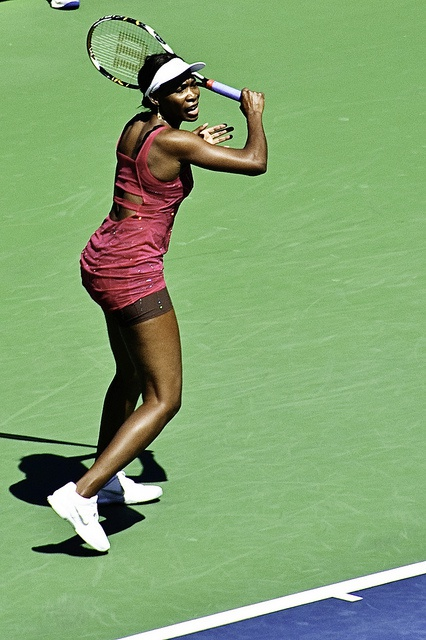Describe the objects in this image and their specific colors. I can see people in black, brown, and maroon tones and tennis racket in black, lightgreen, and green tones in this image. 